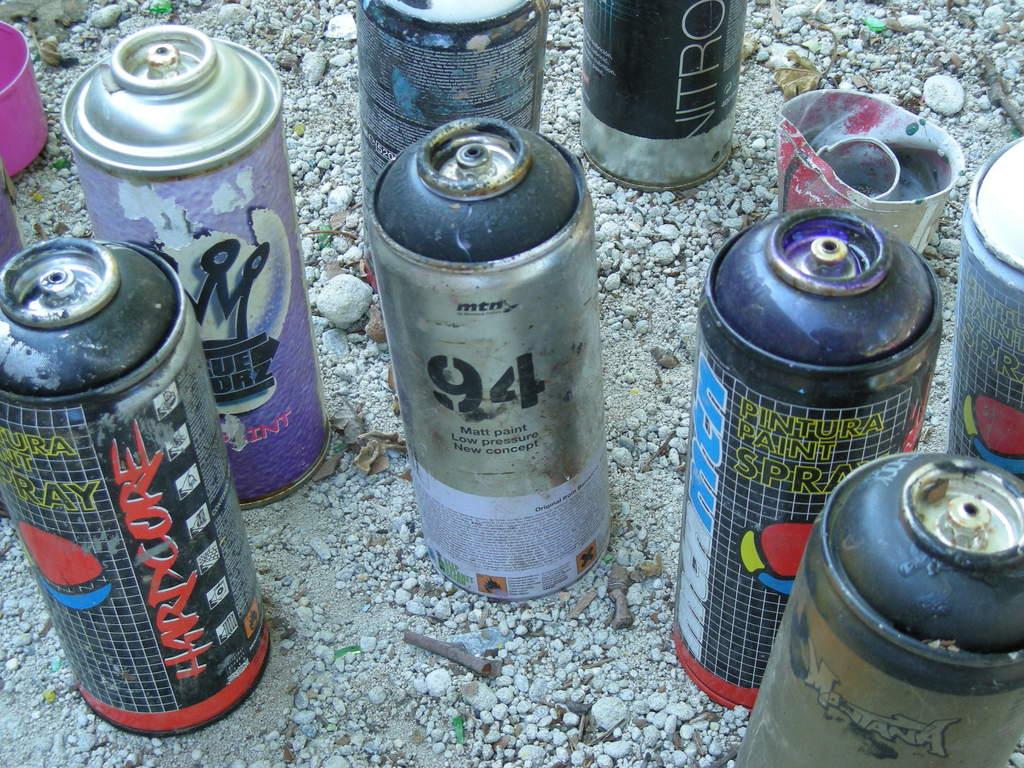What are these sprays used for?
Your response must be concise. Paint. 